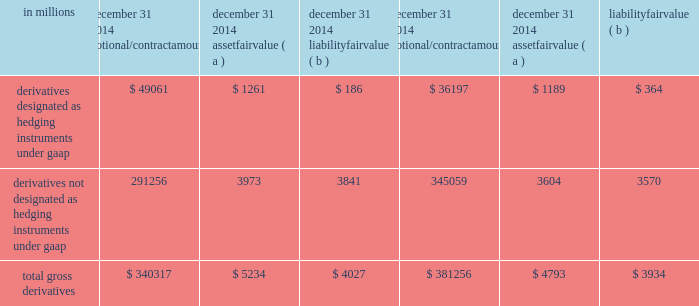Note 15 financial derivatives we use derivative financial instruments ( derivatives ) primarily to help manage exposure to interest rate , market and credit risk and reduce the effects that changes in interest rates may have on net income , the fair value of assets and liabilities , and cash flows .
We also enter into derivatives with customers to facilitate their risk management activities .
Derivatives represent contracts between parties that usually require little or no initial net investment and result in one party delivering cash or another type of asset to the other party based on a notional amount and an underlying as specified in the contract .
Derivative transactions are often measured in terms of notional amount , but this amount is generally not exchanged and it is not recorded on the balance sheet .
The notional amount is the basis to which the underlying is applied to determine required payments under the derivative contract .
The underlying is a referenced interest rate ( commonly libor ) , security price , credit spread or other index .
Residential and commercial real estate loan commitments associated with loans to be sold also qualify as derivative instruments .
The table presents the notional amounts and gross fair values of all derivative assets and liabilities held by pnc : table 124 : total gross derivatives .
( a ) included in other assets on our consolidated balance sheet .
( b ) included in other liabilities on our consolidated balance sheet .
All derivatives are carried on our consolidated balance sheet at fair value .
Derivative balances are presented on the consolidated balance sheet on a net basis taking into consideration the effects of legally enforceable master netting agreements and any related cash collateral exchanged with counterparties .
Further discussion regarding the rights of setoff associated with these legally enforceable master netting agreements is included in the offsetting , counterparty credit risk , and contingent features section below .
Our exposure related to risk participations where we sold protection is discussed in the credit derivatives section below .
Any nonperformance risk , including credit risk , is included in the determination of the estimated net fair value of the derivatives .
Further discussion on how derivatives are accounted for is included in note 1 accounting policies .
Derivatives designated as hedging instruments under gaap certain derivatives used to manage interest rate and foreign exchange risk as part of our asset and liability risk management activities are designated as accounting hedges under gaap .
Derivatives hedging the risks associated with changes in the fair value of assets or liabilities are considered fair value hedges , derivatives hedging the variability of expected future cash flows are considered cash flow hedges , and derivatives hedging a net investment in a foreign subsidiary are considered net investment hedges .
Designating derivatives as accounting hedges allows for gains and losses on those derivatives , to the extent effective , to be recognized in the income statement in the same period the hedged items affect earnings .
The pnc financial services group , inc .
2013 form 10-k 187 .
What percentage of notional contract amount of total gross derivatives at december 31 , 2014 was from derivatives designated as hedging instruments under gaap? 
Computations: (49061 / 340317)
Answer: 0.14416. 